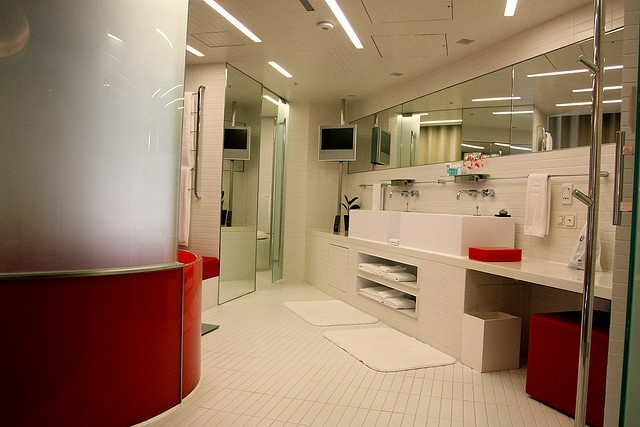Describe the objects in this image and their specific colors. I can see sink in black and tan tones, tv in black, gray, and tan tones, tv in black and gray tones, toilet in black, olive, and tan tones, and potted plant in black, tan, darkgreen, and gray tones in this image. 